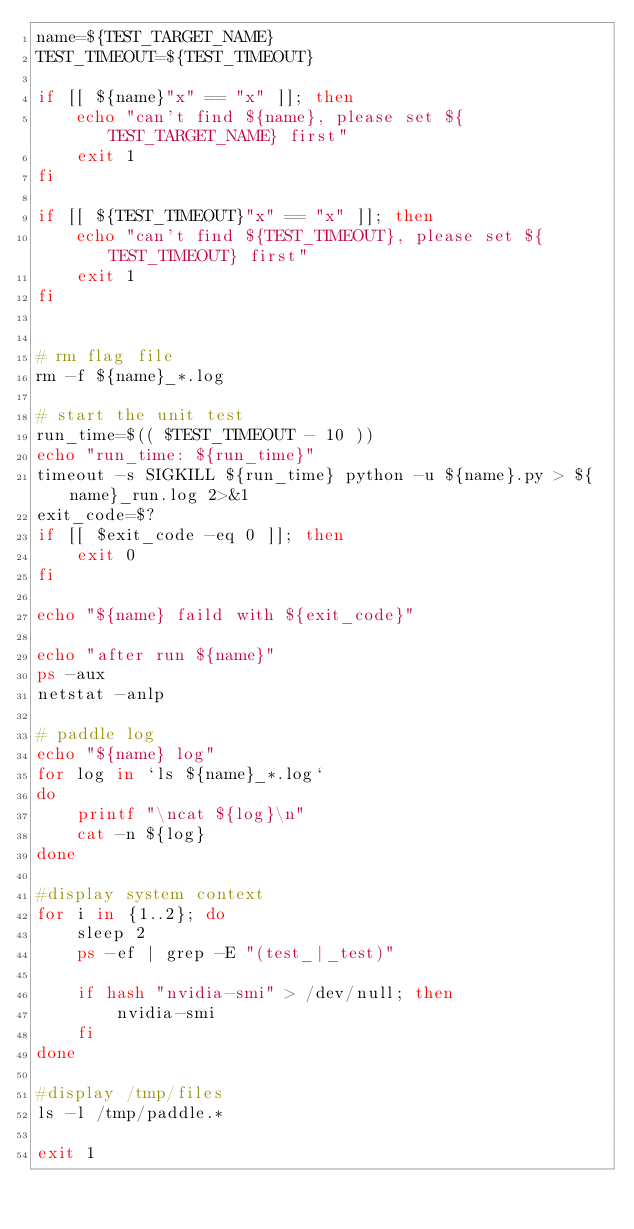Convert code to text. <code><loc_0><loc_0><loc_500><loc_500><_Bash_>name=${TEST_TARGET_NAME}
TEST_TIMEOUT=${TEST_TIMEOUT}

if [[ ${name}"x" == "x" ]]; then
    echo "can't find ${name}, please set ${TEST_TARGET_NAME} first"
    exit 1
fi

if [[ ${TEST_TIMEOUT}"x" == "x" ]]; then
    echo "can't find ${TEST_TIMEOUT}, please set ${TEST_TIMEOUT} first"
    exit 1
fi


# rm flag file
rm -f ${name}_*.log

# start the unit test
run_time=$(( $TEST_TIMEOUT - 10 ))
echo "run_time: ${run_time}"
timeout -s SIGKILL ${run_time} python -u ${name}.py > ${name}_run.log 2>&1
exit_code=$?
if [[ $exit_code -eq 0 ]]; then
    exit 0
fi

echo "${name} faild with ${exit_code}"

echo "after run ${name}"
ps -aux
netstat -anlp

# paddle log
echo "${name} log"
for log in `ls ${name}_*.log`
do
    printf "\ncat ${log}\n"
    cat -n ${log}
done

#display system context
for i in {1..2}; do 
    sleep 2 
    ps -ef | grep -E "(test_|_test)"

    if hash "nvidia-smi" > /dev/null; then
        nvidia-smi
    fi
done

#display /tmp/files
ls -l /tmp/paddle.*

exit 1
</code> 